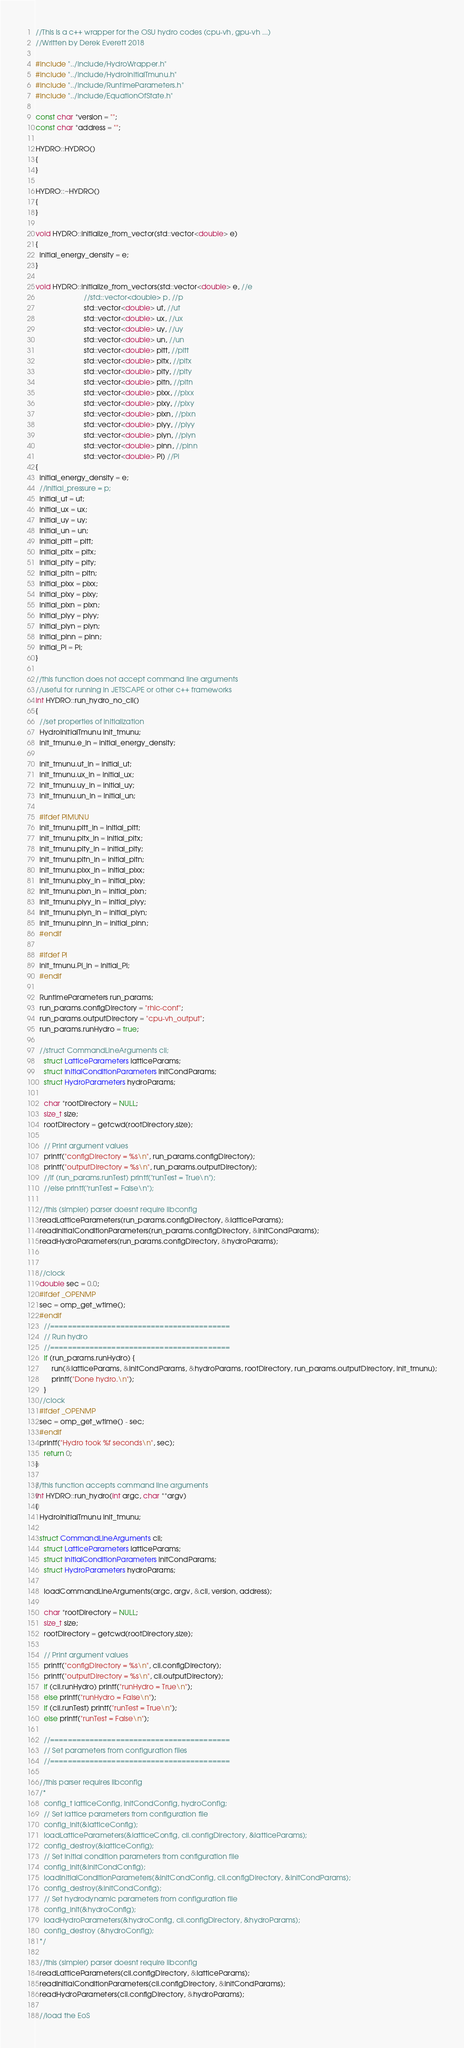<code> <loc_0><loc_0><loc_500><loc_500><_C++_>//This is a c++ wrapper for the OSU hydro codes (cpu-vh, gpu-vh ...)
//Written by Derek Everett 2018

#include "../include/HydroWrapper.h"
#include "../include/HydroInitialTmunu.h"
#include "../include/RuntimeParameters.h"
#include "../include/EquationOfState.h"

const char *version = "";
const char *address = "";

HYDRO::HYDRO()
{
}

HYDRO::~HYDRO()
{
}

void HYDRO::initialize_from_vector(std::vector<double> e)
{
  initial_energy_density = e;
}

void HYDRO::initialize_from_vectors(std::vector<double> e, //e
                        //std::vector<double> p, //p
                        std::vector<double> ut, //ut
                        std::vector<double> ux, //ux
                        std::vector<double> uy, //uy
                        std::vector<double> un, //un
                        std::vector<double> pitt, //pitt
                        std::vector<double> pitx, //pitx
                        std::vector<double> pity, //pity
                        std::vector<double> pitn, //pitn
                        std::vector<double> pixx, //pixx
                        std::vector<double> pixy, //pixy
                        std::vector<double> pixn, //pixn
                        std::vector<double> piyy, //piyy
                        std::vector<double> piyn, //piyn
                        std::vector<double> pinn, //pinn
                        std::vector<double> Pi) //Pi
{
  initial_energy_density = e;
  //initial_pressure = p;
  initial_ut = ut;
  initial_ux = ux;
  initial_uy = uy;
  initial_un = un;
  initial_pitt = pitt;
  initial_pitx = pitx;
  initial_pity = pity;
  initial_pitn = pitn;
  initial_pixx = pixx;
  initial_pixy = pixy;
  initial_pixn = pixn;
  initial_piyy = piyy;
  initial_piyn = piyn;
  initial_pinn = pinn;
  initial_Pi = Pi;
}

//this function does not accept command line arguments
//useful for running in JETSCAPE or other c++ frameworks
int HYDRO::run_hydro_no_cli()
{
  //set properties of initialization
  HydroInitialTmunu init_tmunu;
  init_tmunu.e_in = initial_energy_density;

  init_tmunu.ut_in = initial_ut;
  init_tmunu.ux_in = initial_ux;
  init_tmunu.uy_in = initial_uy;
  init_tmunu.un_in = initial_un;

  #ifdef PIMUNU
  init_tmunu.pitt_in = initial_pitt;
  init_tmunu.pitx_in = initial_pitx;
  init_tmunu.pity_in = initial_pity;
  init_tmunu.pitn_in = initial_pitn;
  init_tmunu.pixx_in = initial_pixx;
  init_tmunu.pixy_in = initial_pixy;
  init_tmunu.pixn_in = initial_pixn;
  init_tmunu.piyy_in = initial_piyy;
  init_tmunu.piyn_in = initial_piyn;
  init_tmunu.pinn_in = initial_pinn;
  #endif

  #ifdef PI
  init_tmunu.Pi_in = initial_Pi;
  #endif

  RuntimeParameters run_params;
  run_params.configDirectory = "rhic-conf";
  run_params.outputDirectory = "cpu-vh_output";
  run_params.runHydro = true;

  //struct CommandLineArguments cli;
	struct LatticeParameters latticeParams;
	struct InitialConditionParameters initCondParams;
	struct HydroParameters hydroParams;

	char *rootDirectory = NULL;
	size_t size;
	rootDirectory = getcwd(rootDirectory,size);

	// Print argument values
	printf("configDirectory = %s\n", run_params.configDirectory);
	printf("outputDirectory = %s\n", run_params.outputDirectory);
	//if (run_params.runTest) printf("runTest = True\n");
	//else printf("runTest = False\n");

  //this (simpler) parser doesnt require libconfig
  readLatticeParameters(run_params.configDirectory, &latticeParams);
  readInitialConditionParameters(run_params.configDirectory, &initCondParams);
  readHydroParameters(run_params.configDirectory, &hydroParams);


  //clock
  double sec = 0.0;
  #ifdef _OPENMP
  sec = omp_get_wtime();
  #endif
	//=========================================
	// Run hydro
	//=========================================
	if (run_params.runHydro) {
		run(&latticeParams, &initCondParams, &hydroParams, rootDirectory, run_params.outputDirectory, init_tmunu);
		printf("Done hydro.\n");
	}
  //clock
  #ifdef _OPENMP
  sec = omp_get_wtime() - sec;
  #endif
  printf("Hydro took %f seconds\n", sec);
	return 0;
}

//this function accepts command line arguments
int HYDRO::run_hydro(int argc, char **argv)
{
  HydroInitialTmunu init_tmunu;

  struct CommandLineArguments cli;
	struct LatticeParameters latticeParams;
	struct InitialConditionParameters initCondParams;
	struct HydroParameters hydroParams;

	loadCommandLineArguments(argc, argv, &cli, version, address);

	char *rootDirectory = NULL;
	size_t size;
	rootDirectory = getcwd(rootDirectory,size);

	// Print argument values
	printf("configDirectory = %s\n", cli.configDirectory);
	printf("outputDirectory = %s\n", cli.outputDirectory);
	if (cli.runHydro) printf("runHydro = True\n");
	else printf("runHydro = False\n");
	if (cli.runTest) printf("runTest = True\n");
	else printf("runTest = False\n");

	//=========================================
	// Set parameters from configuration files
	//=========================================

  //this parser requires libconfig
  /*
	config_t latticeConfig, initCondConfig, hydroConfig;
	// Set lattice parameters from configuration file
	config_init(&latticeConfig);
	loadLatticeParameters(&latticeConfig, cli.configDirectory, &latticeParams);
	config_destroy(&latticeConfig);
	// Set initial condition parameters from configuration file
	config_init(&initCondConfig);
	loadInitialConditionParameters(&initCondConfig, cli.configDirectory, &initCondParams);
	config_destroy(&initCondConfig);
	// Set hydrodynamic parameters from configuration file
	config_init(&hydroConfig);
	loadHydroParameters(&hydroConfig, cli.configDirectory, &hydroParams);
	config_destroy (&hydroConfig);
  */

  //this (simpler) parser doesnt require libconfig
  readLatticeParameters(cli.configDirectory, &latticeParams);
  readInitialConditionParameters(cli.configDirectory, &initCondParams);
  readHydroParameters(cli.configDirectory, &hydroParams);

  //load the EoS</code> 